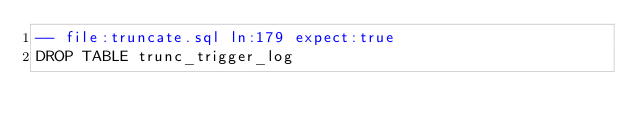Convert code to text. <code><loc_0><loc_0><loc_500><loc_500><_SQL_>-- file:truncate.sql ln:179 expect:true
DROP TABLE trunc_trigger_log
</code> 